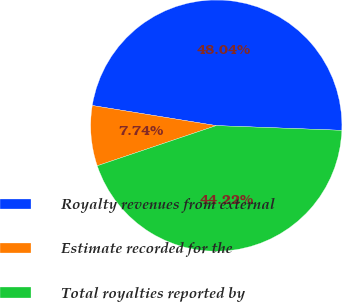Convert chart. <chart><loc_0><loc_0><loc_500><loc_500><pie_chart><fcel>Royalty revenues from external<fcel>Estimate recorded for the<fcel>Total royalties reported by<nl><fcel>48.04%<fcel>7.74%<fcel>44.22%<nl></chart> 